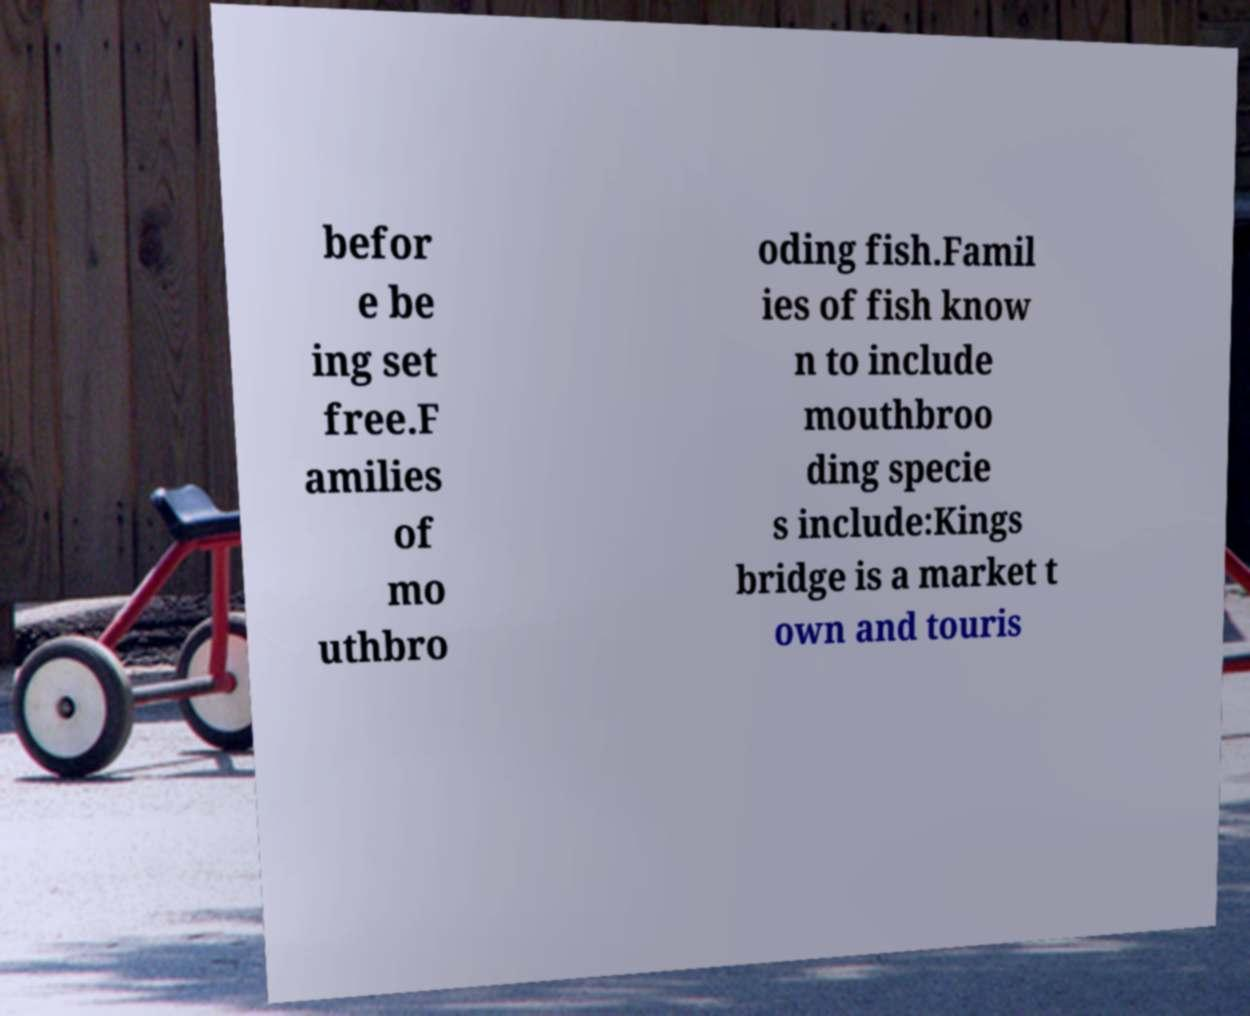For documentation purposes, I need the text within this image transcribed. Could you provide that? befor e be ing set free.F amilies of mo uthbro oding fish.Famil ies of fish know n to include mouthbroo ding specie s include:Kings bridge is a market t own and touris 